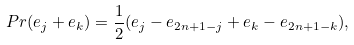<formula> <loc_0><loc_0><loc_500><loc_500>P r ( e _ { j } + e _ { k } ) = { \frac { 1 } { 2 } } ( e _ { j } - e _ { 2 n + 1 - j } + e _ { k } - e _ { 2 n + 1 - k } ) ,</formula> 